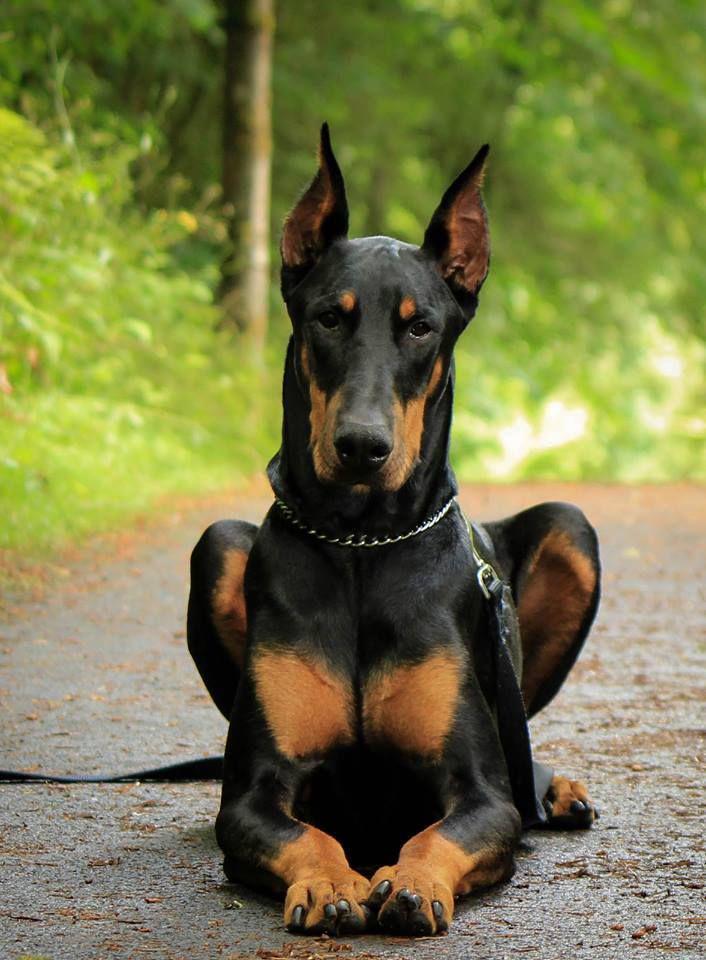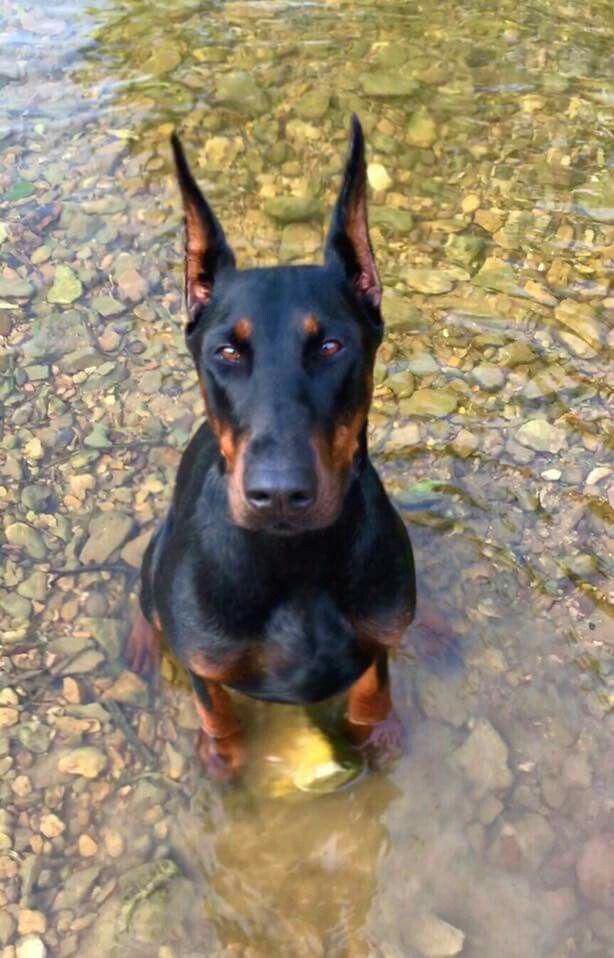The first image is the image on the left, the second image is the image on the right. Given the left and right images, does the statement "One image is a full-grown dog and one is not." hold true? Answer yes or no. No. The first image is the image on the left, the second image is the image on the right. Given the left and right images, does the statement "One image shows a single floppy-eared puppy in a standing pose, and the other image shows an adult dog in profile with its body turned leftward." hold true? Answer yes or no. No. 